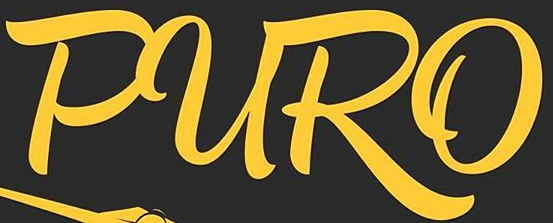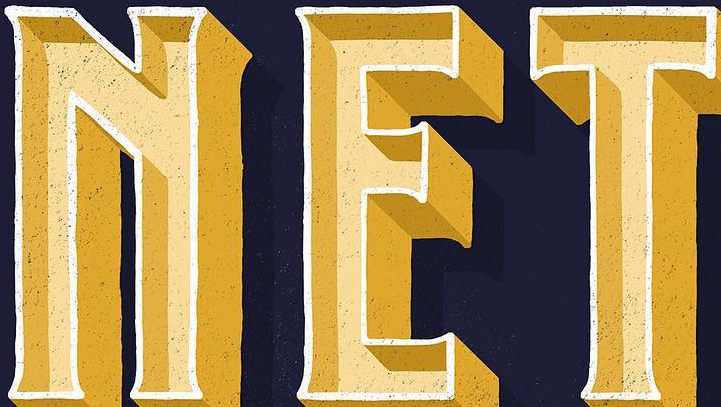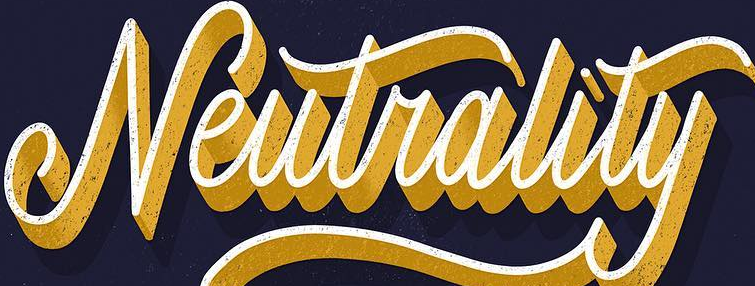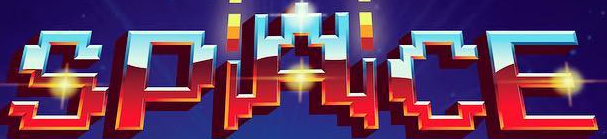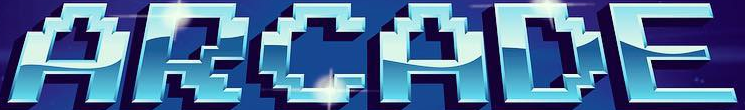What words are shown in these images in order, separated by a semicolon? PURO; NET; Neutrality; SPACE; ARCADE 